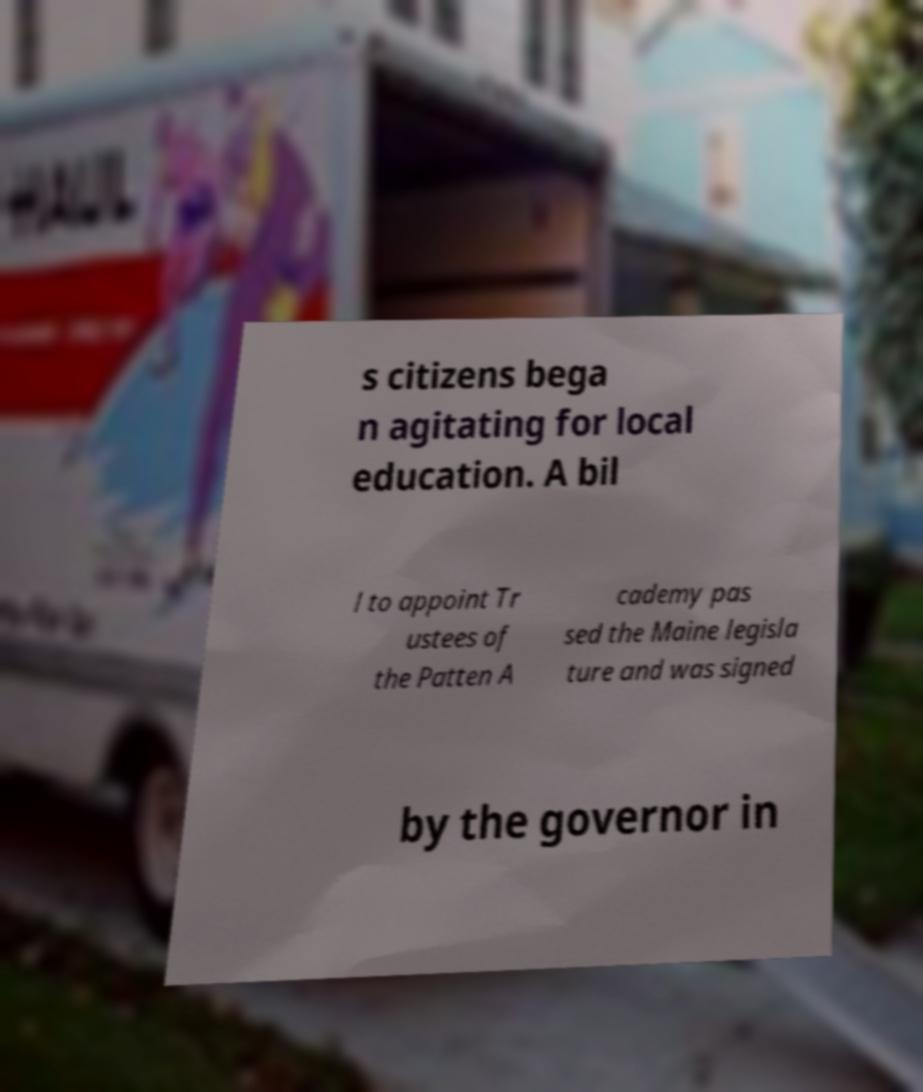Please identify and transcribe the text found in this image. s citizens bega n agitating for local education. A bil l to appoint Tr ustees of the Patten A cademy pas sed the Maine legisla ture and was signed by the governor in 